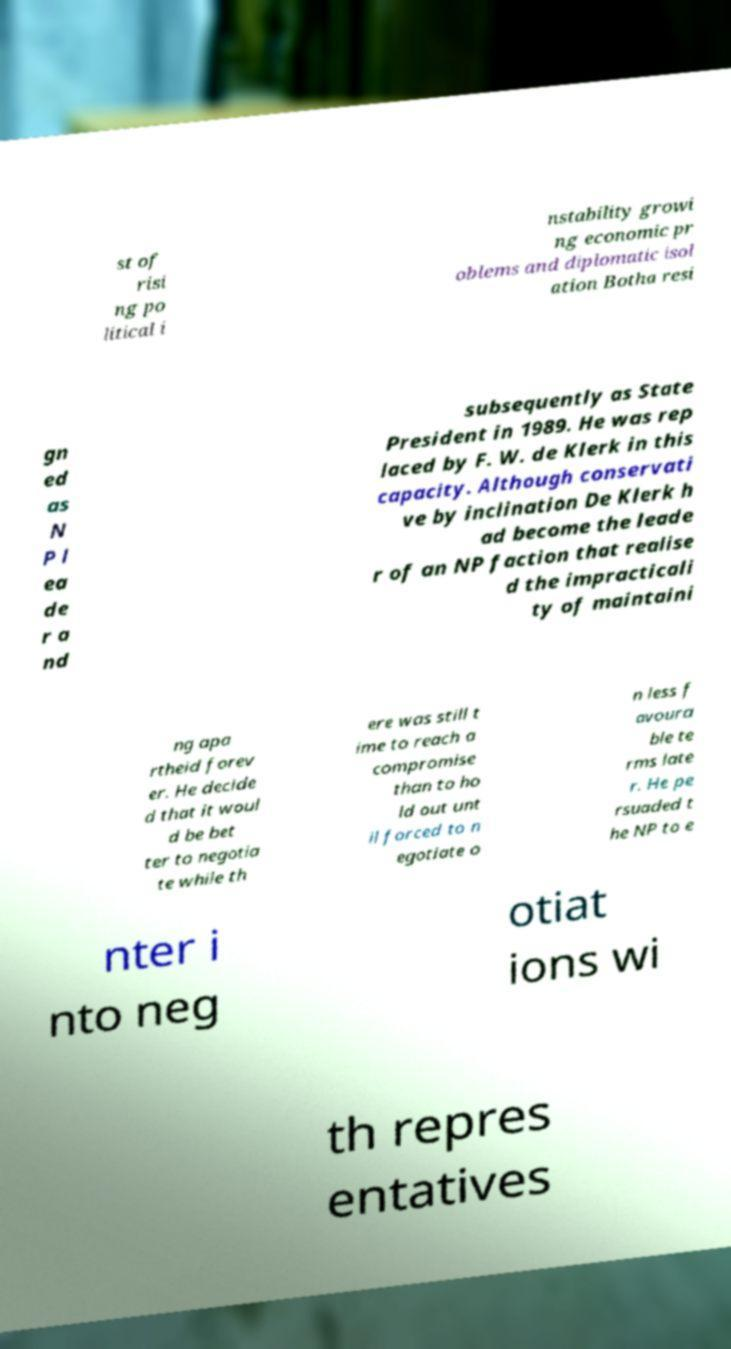Could you extract and type out the text from this image? st of risi ng po litical i nstability growi ng economic pr oblems and diplomatic isol ation Botha resi gn ed as N P l ea de r a nd subsequently as State President in 1989. He was rep laced by F. W. de Klerk in this capacity. Although conservati ve by inclination De Klerk h ad become the leade r of an NP faction that realise d the impracticali ty of maintaini ng apa rtheid forev er. He decide d that it woul d be bet ter to negotia te while th ere was still t ime to reach a compromise than to ho ld out unt il forced to n egotiate o n less f avoura ble te rms late r. He pe rsuaded t he NP to e nter i nto neg otiat ions wi th repres entatives 